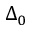<formula> <loc_0><loc_0><loc_500><loc_500>\Delta _ { 0 }</formula> 